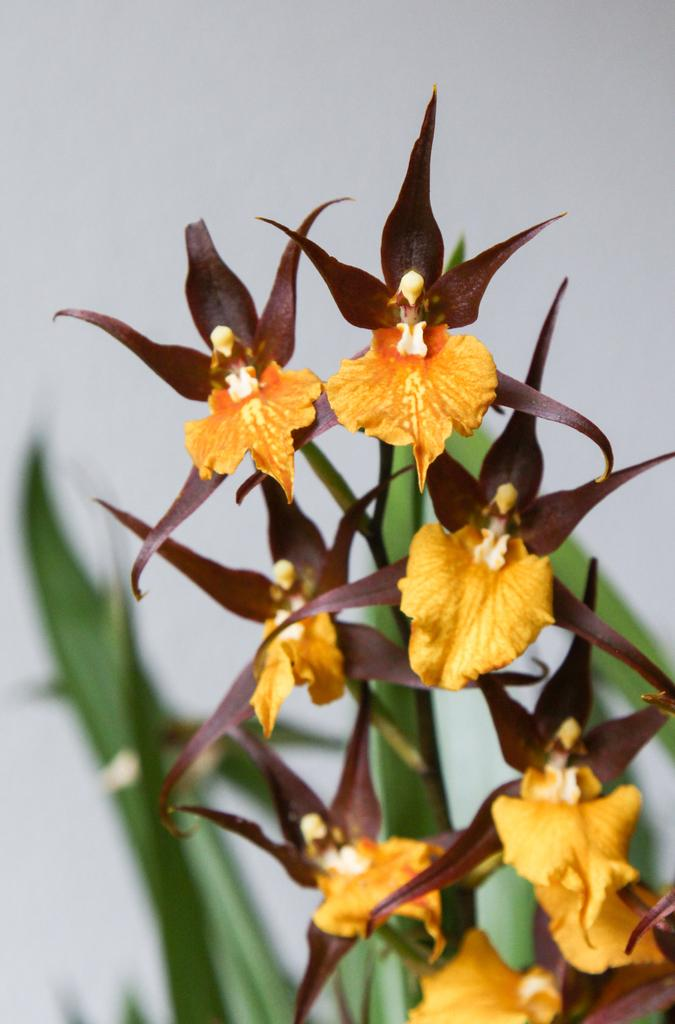What type of plant is visible in the image? There is a plant in the image. What additional features can be seen on the plant? There are flowers in the image. What colors are the flowers? The flowers are yellow and brown in color. Can you describe the background of the image? The background of the image is blurred. Can you see a deer interacting with the plant in the image? There is no deer present in the image. How many curves can be seen in the foot of the plant in the image? The image does not show a foot of the plant, as it is focused on the flowers and the plant itself. 